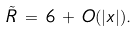<formula> <loc_0><loc_0><loc_500><loc_500>\tilde { R } \, = \, 6 \, + \, O ( | x | ) .</formula> 